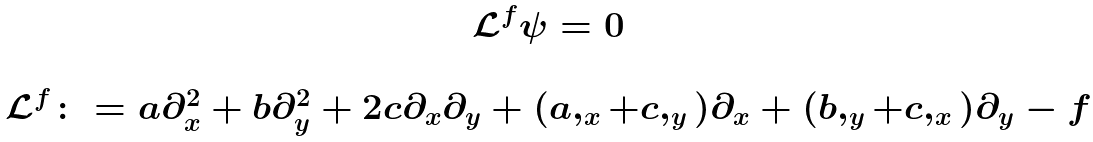Convert formula to latex. <formula><loc_0><loc_0><loc_500><loc_500>\begin{array} { c } { \mathcal { L } } ^ { f } \psi = 0 \\ \\ { \mathcal { L } } ^ { f } \colon = a \partial ^ { 2 } _ { x } + b \partial ^ { 2 } _ { y } + 2 c \partial _ { x } \partial _ { y } + ( a , _ { x } + c , _ { y } ) \partial _ { x } + ( b , _ { y } + c , _ { x } ) \partial _ { y } - f \end{array}</formula> 